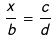Convert formula to latex. <formula><loc_0><loc_0><loc_500><loc_500>\frac { x } { b } = \frac { c } { d }</formula> 